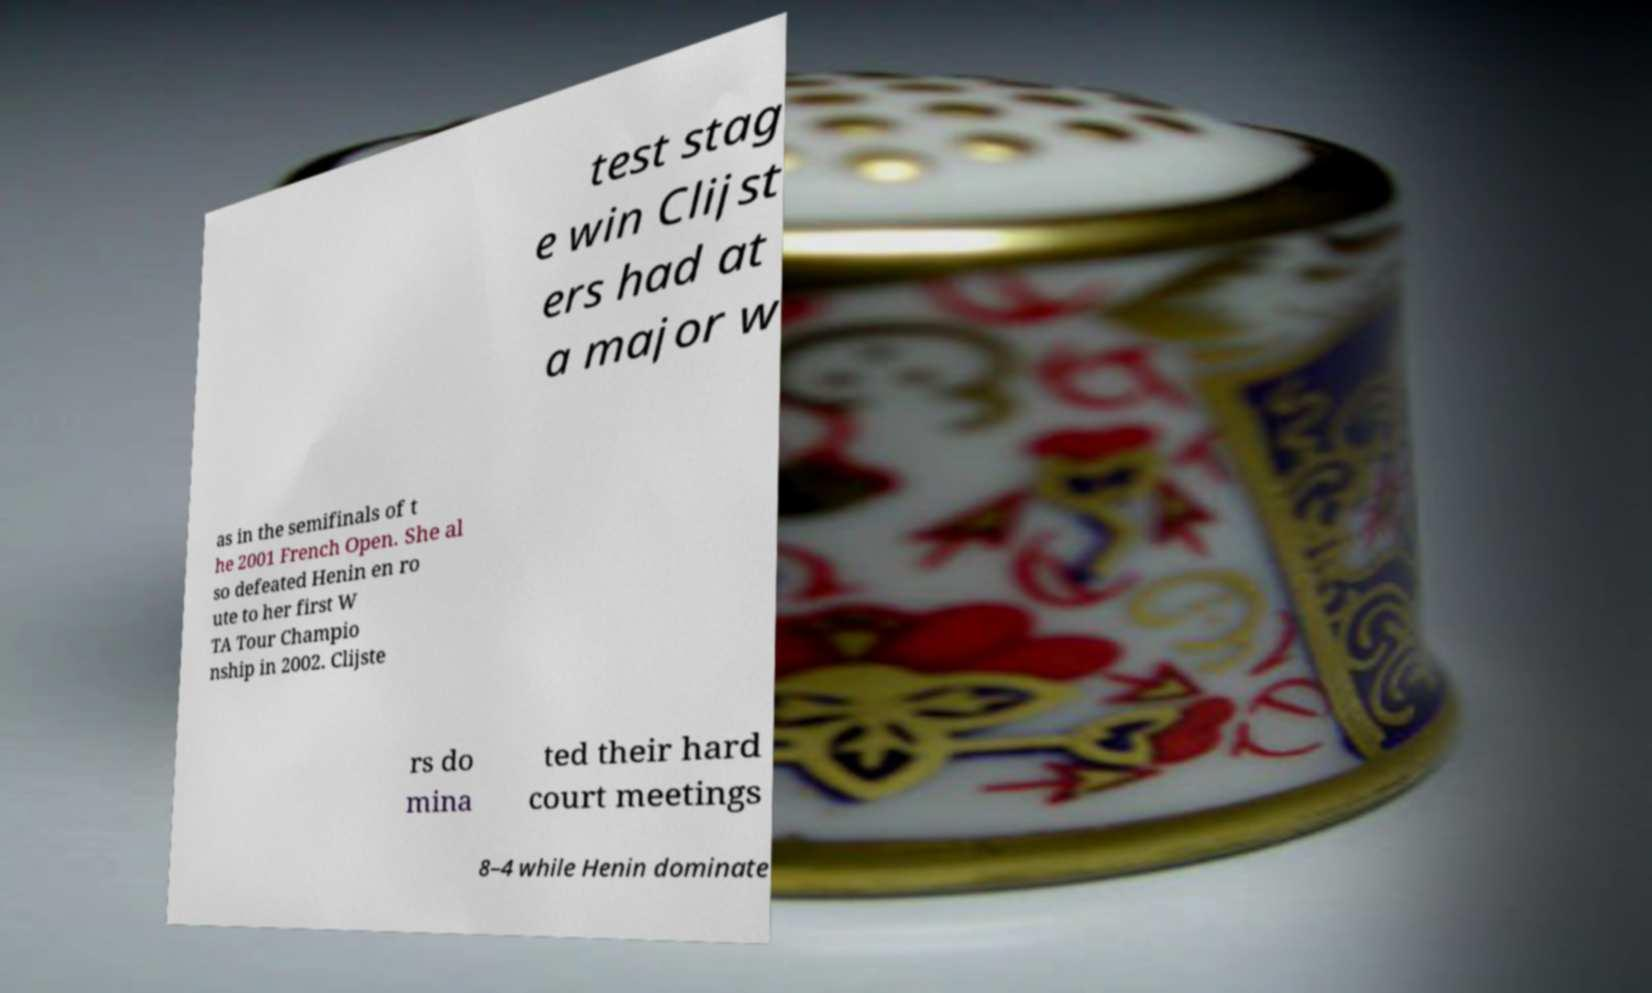What messages or text are displayed in this image? I need them in a readable, typed format. test stag e win Clijst ers had at a major w as in the semifinals of t he 2001 French Open. She al so defeated Henin en ro ute to her first W TA Tour Champio nship in 2002. Clijste rs do mina ted their hard court meetings 8–4 while Henin dominate 